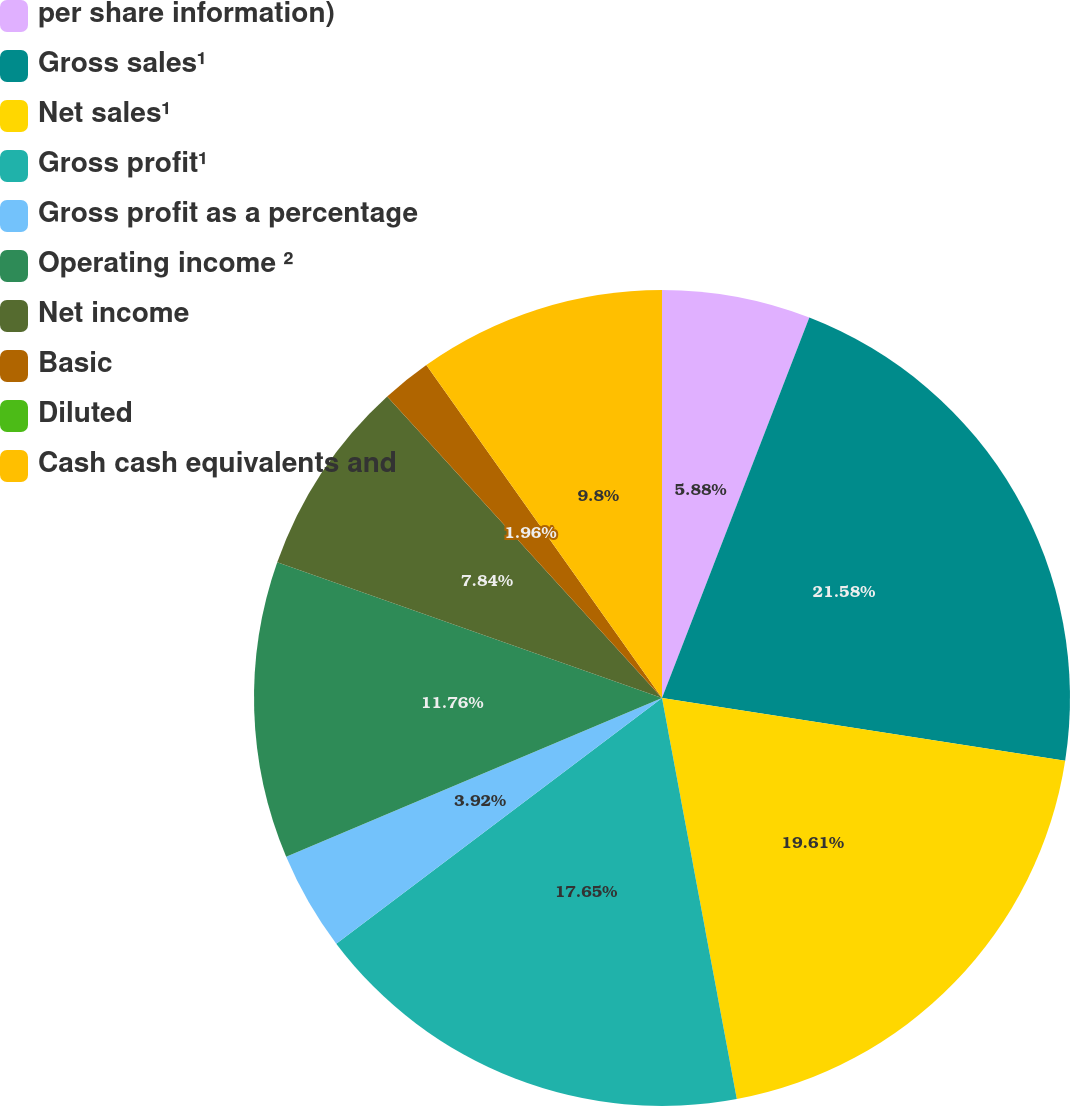<chart> <loc_0><loc_0><loc_500><loc_500><pie_chart><fcel>per share information)<fcel>Gross sales¹<fcel>Net sales¹<fcel>Gross profit¹<fcel>Gross profit as a percentage<fcel>Operating income ²<fcel>Net income<fcel>Basic<fcel>Diluted<fcel>Cash cash equivalents and<nl><fcel>5.88%<fcel>21.57%<fcel>19.61%<fcel>17.65%<fcel>3.92%<fcel>11.76%<fcel>7.84%<fcel>1.96%<fcel>0.0%<fcel>9.8%<nl></chart> 